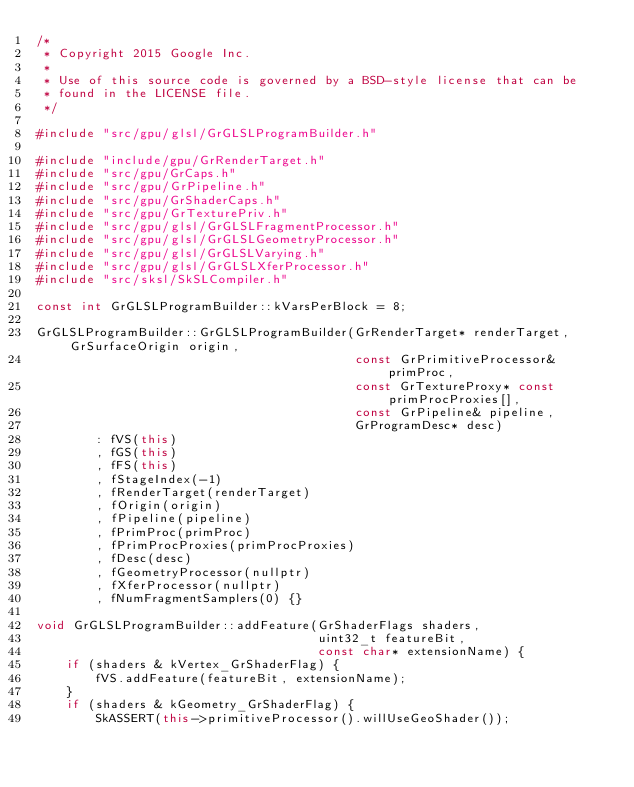<code> <loc_0><loc_0><loc_500><loc_500><_C++_>/*
 * Copyright 2015 Google Inc.
 *
 * Use of this source code is governed by a BSD-style license that can be
 * found in the LICENSE file.
 */

#include "src/gpu/glsl/GrGLSLProgramBuilder.h"

#include "include/gpu/GrRenderTarget.h"
#include "src/gpu/GrCaps.h"
#include "src/gpu/GrPipeline.h"
#include "src/gpu/GrShaderCaps.h"
#include "src/gpu/GrTexturePriv.h"
#include "src/gpu/glsl/GrGLSLFragmentProcessor.h"
#include "src/gpu/glsl/GrGLSLGeometryProcessor.h"
#include "src/gpu/glsl/GrGLSLVarying.h"
#include "src/gpu/glsl/GrGLSLXferProcessor.h"
#include "src/sksl/SkSLCompiler.h"

const int GrGLSLProgramBuilder::kVarsPerBlock = 8;

GrGLSLProgramBuilder::GrGLSLProgramBuilder(GrRenderTarget* renderTarget, GrSurfaceOrigin origin,
                                           const GrPrimitiveProcessor& primProc,
                                           const GrTextureProxy* const primProcProxies[],
                                           const GrPipeline& pipeline,
                                           GrProgramDesc* desc)
        : fVS(this)
        , fGS(this)
        , fFS(this)
        , fStageIndex(-1)
        , fRenderTarget(renderTarget)
        , fOrigin(origin)
        , fPipeline(pipeline)
        , fPrimProc(primProc)
        , fPrimProcProxies(primProcProxies)
        , fDesc(desc)
        , fGeometryProcessor(nullptr)
        , fXferProcessor(nullptr)
        , fNumFragmentSamplers(0) {}

void GrGLSLProgramBuilder::addFeature(GrShaderFlags shaders,
                                      uint32_t featureBit,
                                      const char* extensionName) {
    if (shaders & kVertex_GrShaderFlag) {
        fVS.addFeature(featureBit, extensionName);
    }
    if (shaders & kGeometry_GrShaderFlag) {
        SkASSERT(this->primitiveProcessor().willUseGeoShader());</code> 